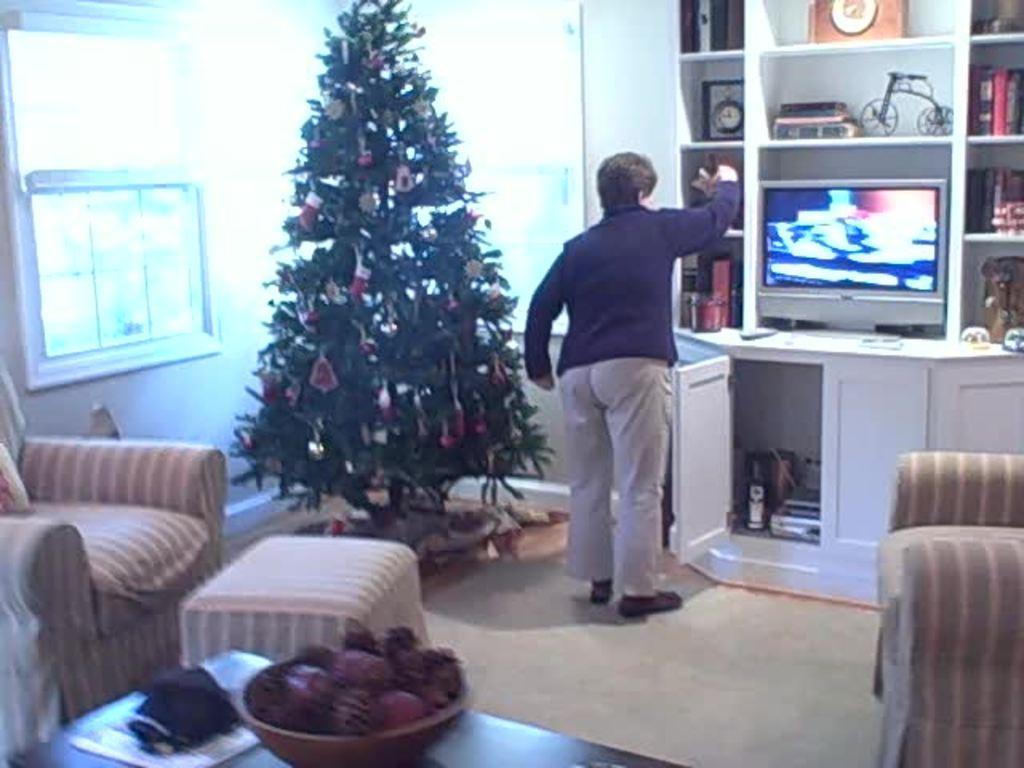Could you give a brief overview of what you see in this image? In the image we can see there is a person standing and there are decorative items and books kept in the shelves. There is a decorated christmas tree and there are fruits kept in the bowl. There are chairs and there is window on the wall. 